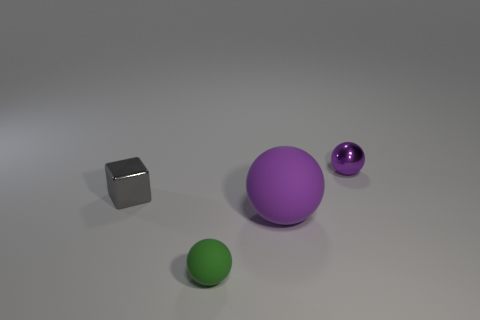Are there any tiny metal blocks behind the small green rubber object?
Make the answer very short. Yes. Is the tiny ball that is behind the green rubber object made of the same material as the gray block?
Make the answer very short. Yes. Are there any small spheres that have the same color as the big rubber object?
Ensure brevity in your answer.  Yes. What is the shape of the tiny gray shiny object?
Your response must be concise. Cube. The small ball that is in front of the small metallic object that is in front of the tiny purple metal thing is what color?
Your answer should be very brief. Green. What is the size of the object that is behind the gray block?
Your answer should be compact. Small. Are there any purple objects made of the same material as the gray block?
Your answer should be very brief. Yes. How many green metallic things are the same shape as the small purple thing?
Offer a very short reply. 0. The small shiny object that is right of the tiny shiny object that is to the left of the purple sphere that is behind the big purple thing is what shape?
Offer a very short reply. Sphere. What is the material of the object that is both on the right side of the gray cube and to the left of the purple matte sphere?
Keep it short and to the point. Rubber. 